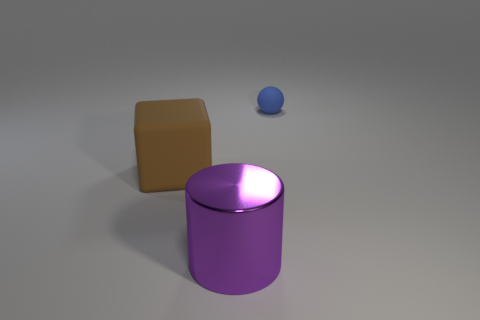Subtract all yellow balls. Subtract all purple cylinders. How many balls are left? 1 Add 2 brown blocks. How many objects exist? 5 Subtract all blocks. How many objects are left? 2 Add 2 cubes. How many cubes are left? 3 Add 1 brown cubes. How many brown cubes exist? 2 Subtract 1 purple cylinders. How many objects are left? 2 Subtract all large cyan blocks. Subtract all rubber things. How many objects are left? 1 